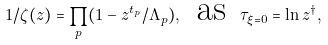<formula> <loc_0><loc_0><loc_500><loc_500>1 / \zeta ( z ) = \prod _ { p } ( 1 - z ^ { t _ { p } } / \Lambda _ { p } ) , \, \text { as } \, \tau _ { \xi = 0 } = \ln z ^ { \dagger } ,</formula> 